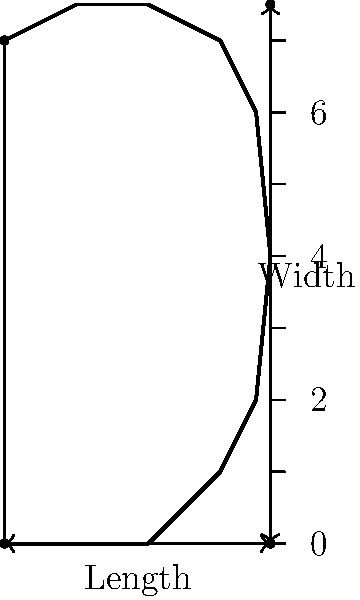Based on the foot measurement diagram provided, which of the following statements is most accurate for determining the optimal sneaker fit?

A) The sneaker should be exactly the same length as the foot measurement.
B) The sneaker should be 0.5 cm longer than the foot measurement.
C) The sneaker should be 1-1.5 cm longer than the foot measurement.
D) The sneaker should be 2 cm longer than the foot measurement. To determine the optimal sneaker fit using the foot measurement diagram, we need to consider the following steps:

1. Understand the purpose of extra space: When fitting sneakers, it's important to allow for some extra space at the toe area. This accommodates foot swelling during activity and prevents toes from hitting the front of the shoe.

2. Industry standard: The generally accepted rule in the footwear industry is to allow for approximately 1-1.5 cm (or about 3/8 to 1/2 inch) of space between the end of the longest toe and the front of the shoe.

3. Analyzing the options:
   A) Exact length: This would be too tight and uncomfortable, especially during activity.
   B) 0.5 cm longer: This provides some space but is still considered insufficient for most people.
   C) 1-1.5 cm longer: This aligns with the industry standard and provides optimal comfort and fit.
   D) 2 cm longer: While this provides ample space, it might be too loose for most people, potentially causing blisters or reducing stability.

4. Considering width: Although not directly addressed in the question, it's worth noting that the width measurement is also crucial for a proper fit. The sneaker should comfortably accommodate the widest part of the foot without being too loose.

5. Personal comfort: While the 1-1.5 cm rule is a good general guideline, personal preference and foot shape can influence the ideal fit. Some individuals might prefer slightly more or less space.

Given these considerations, the most accurate statement for determining optimal sneaker fit based on the foot measurement diagram is option C: The sneaker should be 1-1.5 cm longer than the foot measurement.
Answer: C) The sneaker should be 1-1.5 cm longer than the foot measurement. 